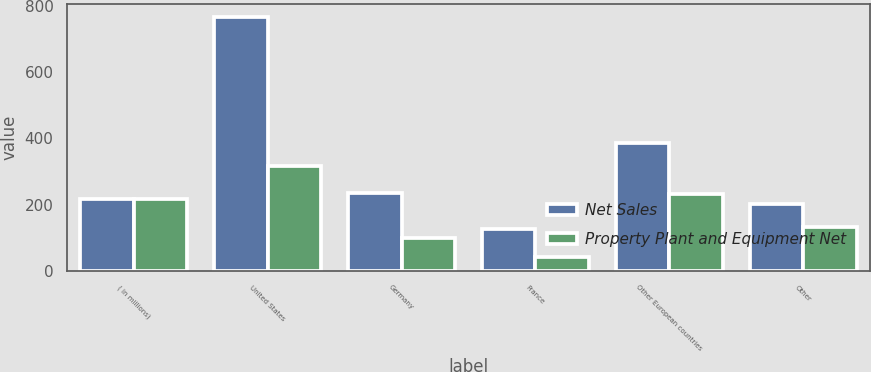<chart> <loc_0><loc_0><loc_500><loc_500><stacked_bar_chart><ecel><fcel>( in millions)<fcel>United States<fcel>Germany<fcel>France<fcel>Other European countries<fcel>Other<nl><fcel>Net Sales<fcel>217.15<fcel>766.1<fcel>235.9<fcel>127.5<fcel>386.1<fcel>201.8<nl><fcel>Property Plant and Equipment Net<fcel>217.15<fcel>315.3<fcel>99.3<fcel>42.5<fcel>232.5<fcel>132.4<nl></chart> 